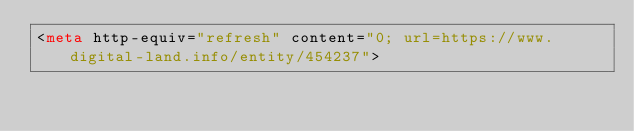Convert code to text. <code><loc_0><loc_0><loc_500><loc_500><_HTML_><meta http-equiv="refresh" content="0; url=https://www.digital-land.info/entity/454237"></code> 